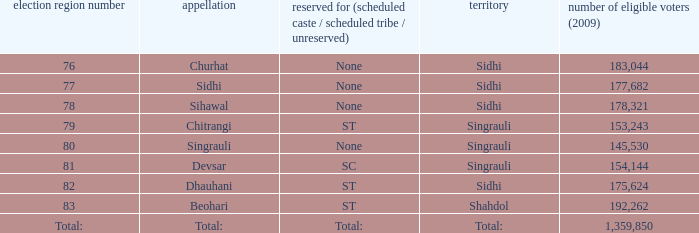What is Beohari's highest number of electorates? 192262.0. Could you help me parse every detail presented in this table? {'header': ['election region number', 'appellation', 'reserved for (scheduled caste / scheduled tribe / unreserved)', 'territory', 'number of eligible voters (2009)'], 'rows': [['76', 'Churhat', 'None', 'Sidhi', '183,044'], ['77', 'Sidhi', 'None', 'Sidhi', '177,682'], ['78', 'Sihawal', 'None', 'Sidhi', '178,321'], ['79', 'Chitrangi', 'ST', 'Singrauli', '153,243'], ['80', 'Singrauli', 'None', 'Singrauli', '145,530'], ['81', 'Devsar', 'SC', 'Singrauli', '154,144'], ['82', 'Dhauhani', 'ST', 'Sidhi', '175,624'], ['83', 'Beohari', 'ST', 'Shahdol', '192,262'], ['Total:', 'Total:', 'Total:', 'Total:', '1,359,850']]} 